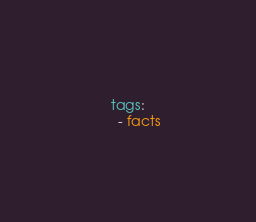<code> <loc_0><loc_0><loc_500><loc_500><_YAML_>    tags:
      - facts
</code> 